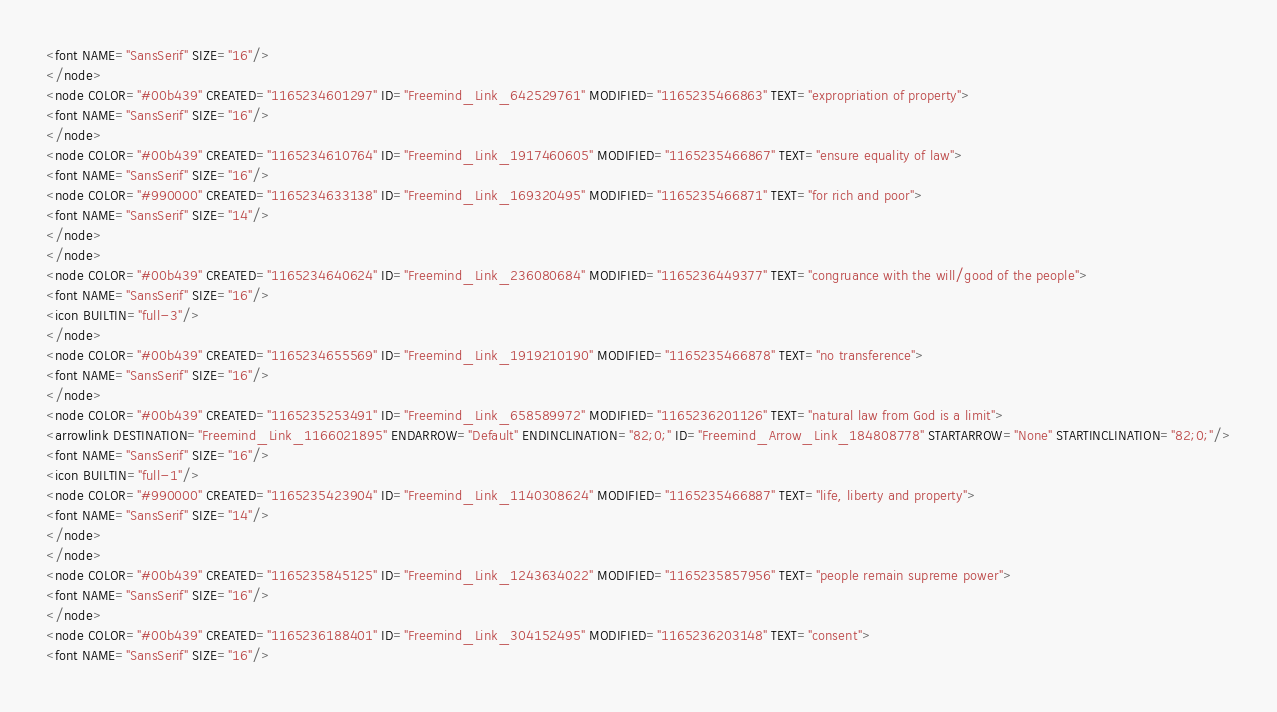Convert code to text. <code><loc_0><loc_0><loc_500><loc_500><_ObjectiveC_><font NAME="SansSerif" SIZE="16"/>
</node>
<node COLOR="#00b439" CREATED="1165234601297" ID="Freemind_Link_642529761" MODIFIED="1165235466863" TEXT="expropriation of property">
<font NAME="SansSerif" SIZE="16"/>
</node>
<node COLOR="#00b439" CREATED="1165234610764" ID="Freemind_Link_1917460605" MODIFIED="1165235466867" TEXT="ensure equality of law">
<font NAME="SansSerif" SIZE="16"/>
<node COLOR="#990000" CREATED="1165234633138" ID="Freemind_Link_169320495" MODIFIED="1165235466871" TEXT="for rich and poor">
<font NAME="SansSerif" SIZE="14"/>
</node>
</node>
<node COLOR="#00b439" CREATED="1165234640624" ID="Freemind_Link_236080684" MODIFIED="1165236449377" TEXT="congruance with the will/good of the people">
<font NAME="SansSerif" SIZE="16"/>
<icon BUILTIN="full-3"/>
</node>
<node COLOR="#00b439" CREATED="1165234655569" ID="Freemind_Link_1919210190" MODIFIED="1165235466878" TEXT="no transference">
<font NAME="SansSerif" SIZE="16"/>
</node>
<node COLOR="#00b439" CREATED="1165235253491" ID="Freemind_Link_658589972" MODIFIED="1165236201126" TEXT="natural law from God is a limit">
<arrowlink DESTINATION="Freemind_Link_1166021895" ENDARROW="Default" ENDINCLINATION="82;0;" ID="Freemind_Arrow_Link_184808778" STARTARROW="None" STARTINCLINATION="82;0;"/>
<font NAME="SansSerif" SIZE="16"/>
<icon BUILTIN="full-1"/>
<node COLOR="#990000" CREATED="1165235423904" ID="Freemind_Link_1140308624" MODIFIED="1165235466887" TEXT="life, liberty and property">
<font NAME="SansSerif" SIZE="14"/>
</node>
</node>
<node COLOR="#00b439" CREATED="1165235845125" ID="Freemind_Link_1243634022" MODIFIED="1165235857956" TEXT="people remain supreme power">
<font NAME="SansSerif" SIZE="16"/>
</node>
<node COLOR="#00b439" CREATED="1165236188401" ID="Freemind_Link_304152495" MODIFIED="1165236203148" TEXT="consent">
<font NAME="SansSerif" SIZE="16"/></code> 